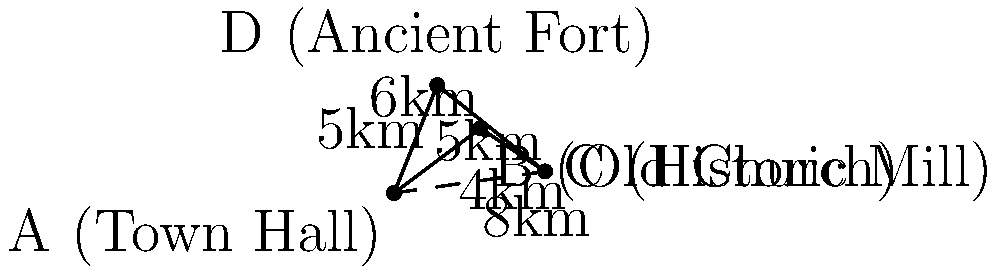As a local historian planning a heritage trail, you need to determine the most efficient route connecting four historical landmarks: the Town Hall (A), Old Church (B), Historic Mill (C), and Ancient Fort (D). The distances between adjacent landmarks are shown in the diagram. If you want to create a trail that visits all landmarks and returns to the starting point, which route would minimize the total distance traveled? Calculate the difference in distance between the optimal route and the route A-B-C-D-A. To solve this problem, we need to compare the total distances of different possible routes:

1. Route A-B-C-D-A:
   Distance = 5 + 4 + 6 + 5 = 20 km

2. Route A-C-B-D-A (using the diagonal A-C):
   Distance = 8 + 4 + 5 + 5 = 22 km

3. Route A-D-C-B-A:
   Distance = 5 + 6 + 4 + 5 = 20 km

4. Route A-B-D-C-A:
   Distance = 5 + 5 + 6 + 8 = 24 km

The optimal route is either A-B-C-D-A or A-D-C-B-A, both with a total distance of 20 km.

Since the question asks for the difference between the optimal route and A-B-C-D-A, and they are the same, the difference is 0 km.

It's worth noting that in this case, the diagonal A-C doesn't provide a shorter overall route, despite being shorter than A-B-C.
Answer: 0 km 